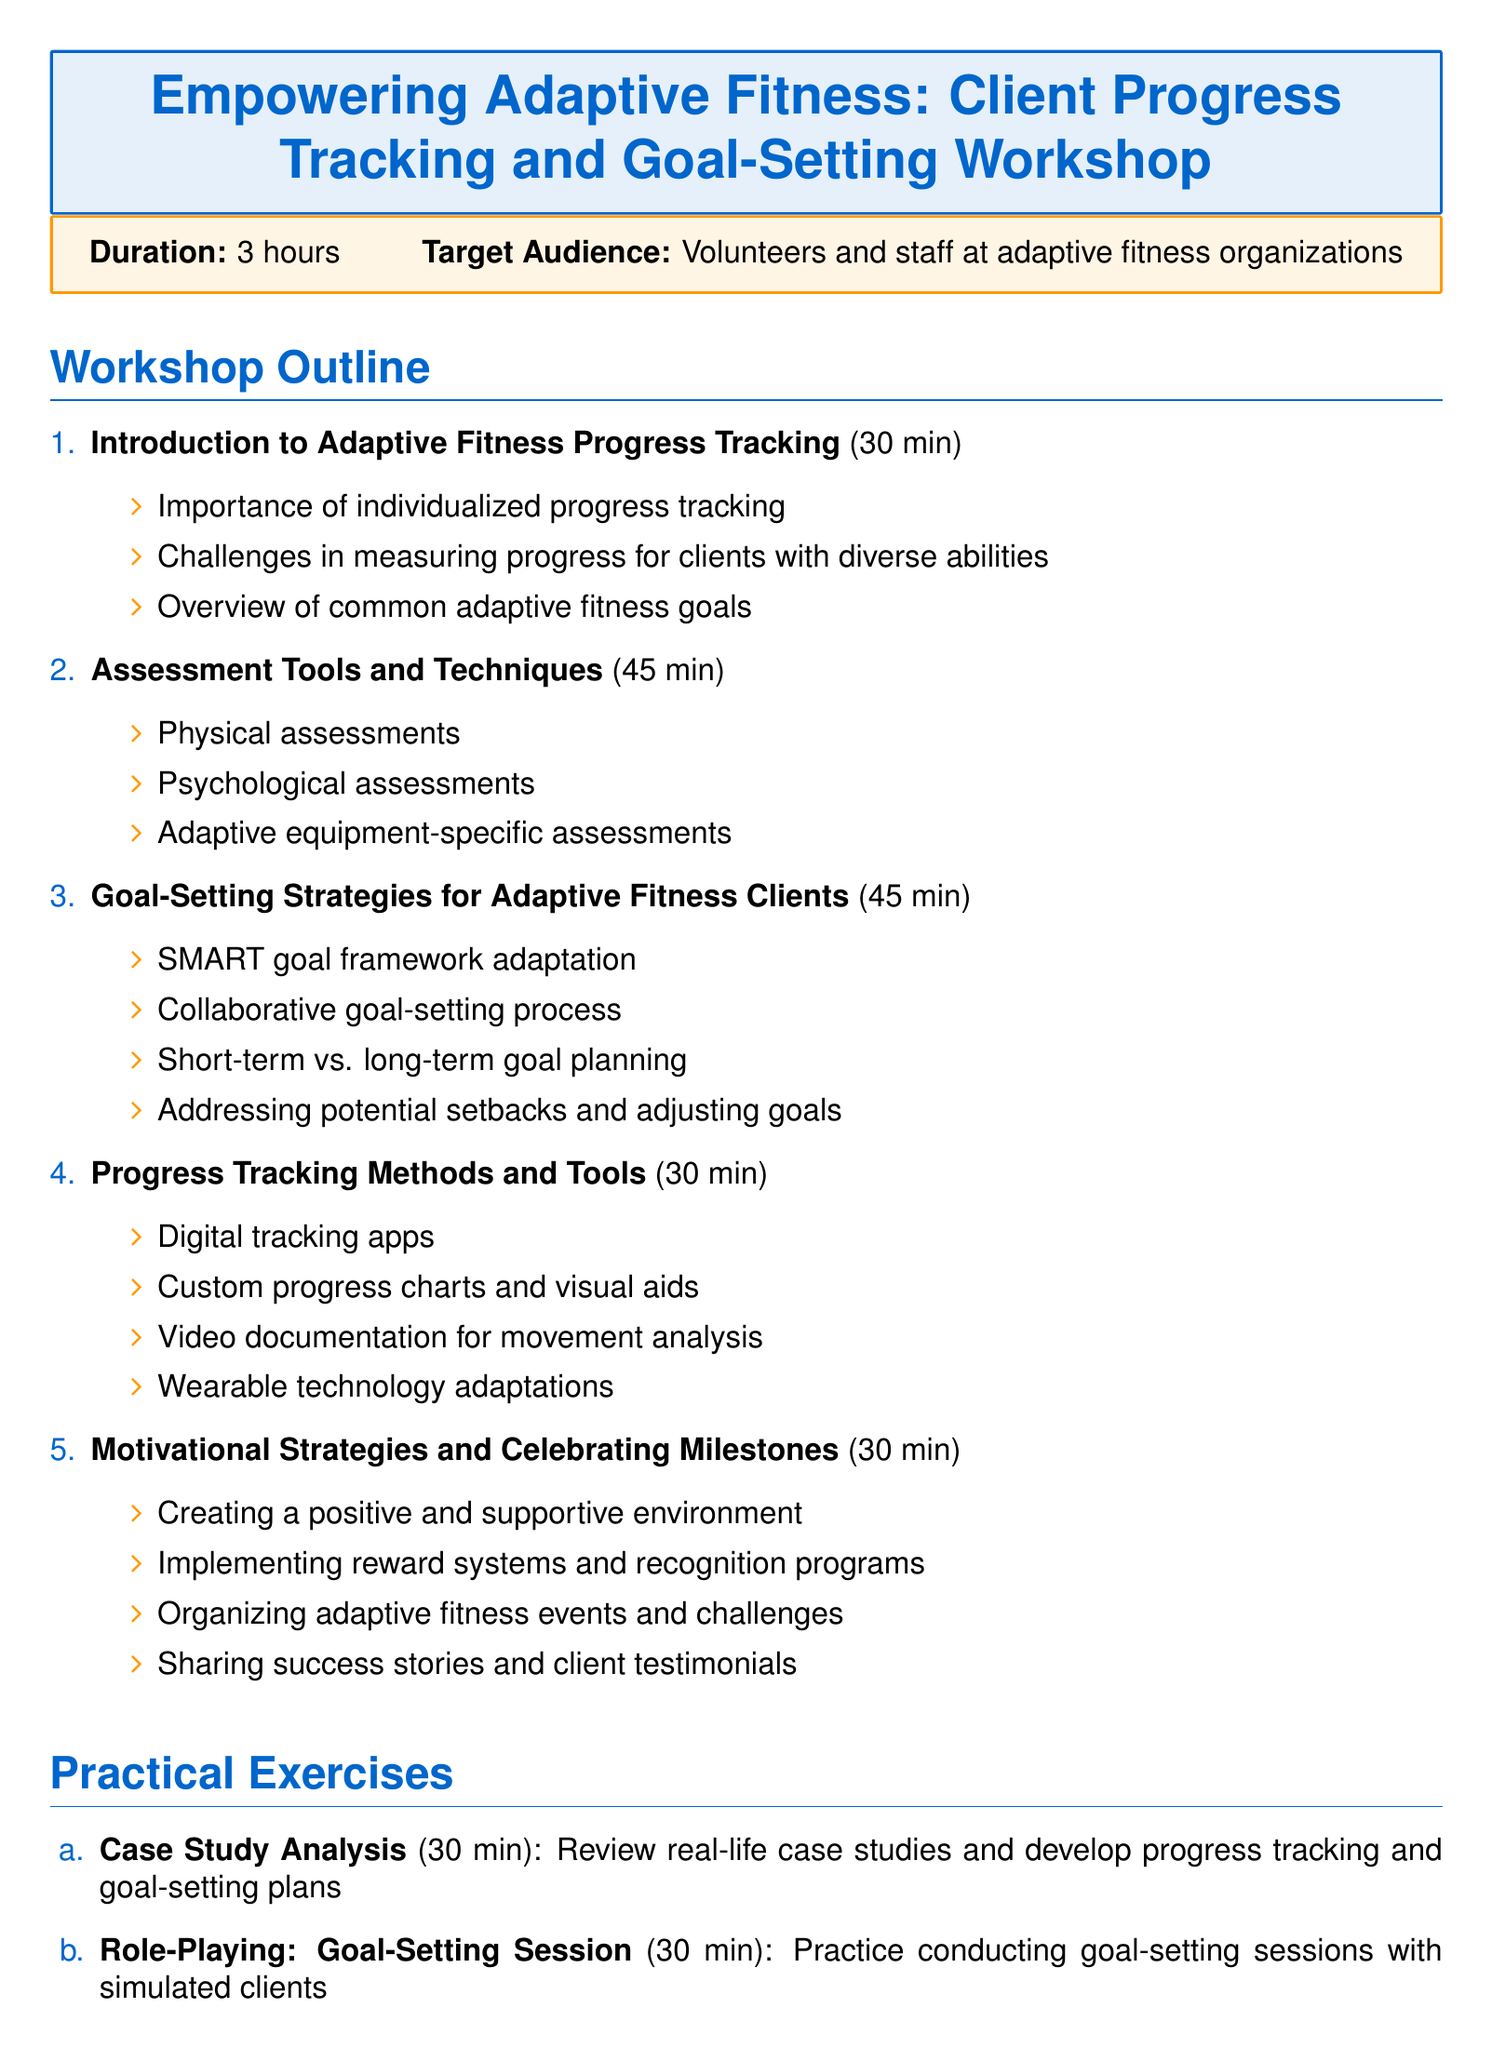What is the workshop title? The workshop title is provided at the beginning of the document and is "Empowering Adaptive Fitness: Client Progress Tracking and Goal-Setting Workshop."
Answer: Empowering Adaptive Fitness: Client Progress Tracking and Goal-Setting Workshop How long is the workshop? The duration of the workshop is stated in the second section of the document, which is 3 hours.
Answer: 3 hours Who is the guest speaker? The document specifies that the guest speaker is Dr. Sarah Thompson, with details about her role and organization.
Answer: Dr. Sarah Thompson What is the first main section of the workshop? The first main section is outlined clearly in the workshop structure, identified as "Introduction to Adaptive Fitness Progress Tracking."
Answer: Introduction to Adaptive Fitness Progress Tracking What are the practical exercises included in the workshop? The document lists two practical exercises included in the workshop, providing their titles and descriptions.
Answer: Case Study Analysis, Role-Playing: Goal-Setting Session How many minutes are allocated to the "Motivational Strategies and Celebrating Milestones" section? The duration allocated to this section is indicated next to its title in the document, which is 30 minutes.
Answer: 30 minutes What is the topic of the guest speaker's presentation? The topic of the guest speaker’s presentation is specified immediately following her name, focusing on measuring functional improvements in adaptive fitness clients.
Answer: Innovative Approaches to Measuring Functional Improvements in Adaptive Fitness Clients What type of audience is the workshop targeting? The target audience is mentioned early in the document, which identifies them as volunteers and staff at adaptive fitness organizations.
Answer: Volunteers and staff at adaptive fitness organizations 